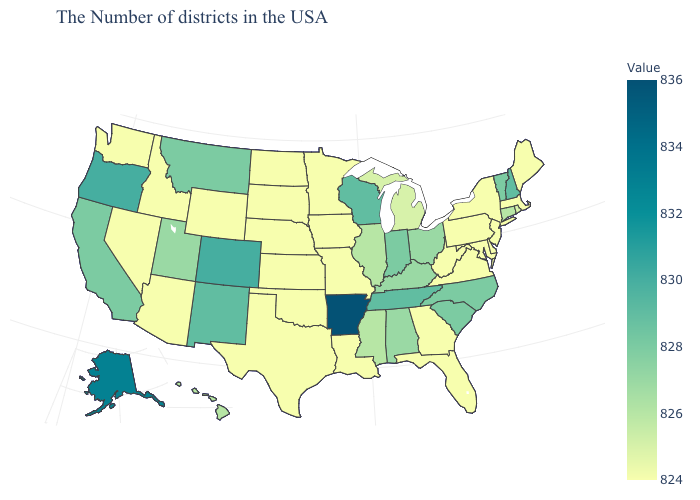Does the map have missing data?
Write a very short answer. No. Which states have the lowest value in the MidWest?
Keep it brief. Missouri, Minnesota, Iowa, Kansas, Nebraska, South Dakota, North Dakota. Does New Hampshire have the highest value in the Northeast?
Concise answer only. Yes. Which states have the lowest value in the USA?
Short answer required. Maine, Massachusetts, New York, New Jersey, Delaware, Maryland, Pennsylvania, Virginia, West Virginia, Florida, Georgia, Louisiana, Missouri, Minnesota, Iowa, Kansas, Nebraska, Oklahoma, Texas, South Dakota, North Dakota, Wyoming, Arizona, Idaho, Nevada, Washington. 